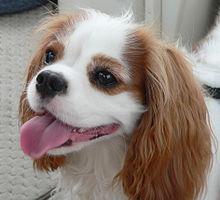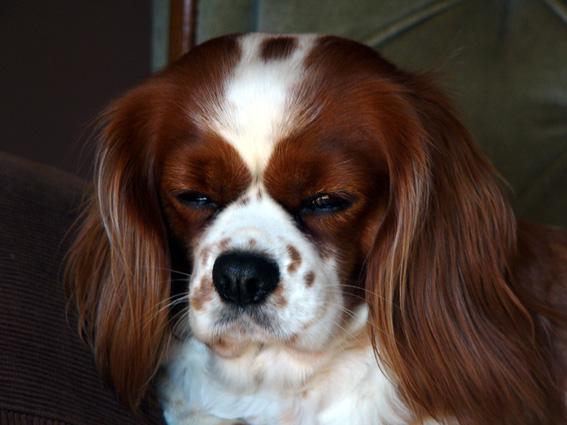The first image is the image on the left, the second image is the image on the right. Evaluate the accuracy of this statement regarding the images: "An image contains a dog attached to a leash.". Is it true? Answer yes or no. No. The first image is the image on the left, the second image is the image on the right. Considering the images on both sides, is "Right and left images contain the same number of spaniels, and all dogs are turned mostly frontward." valid? Answer yes or no. Yes. 